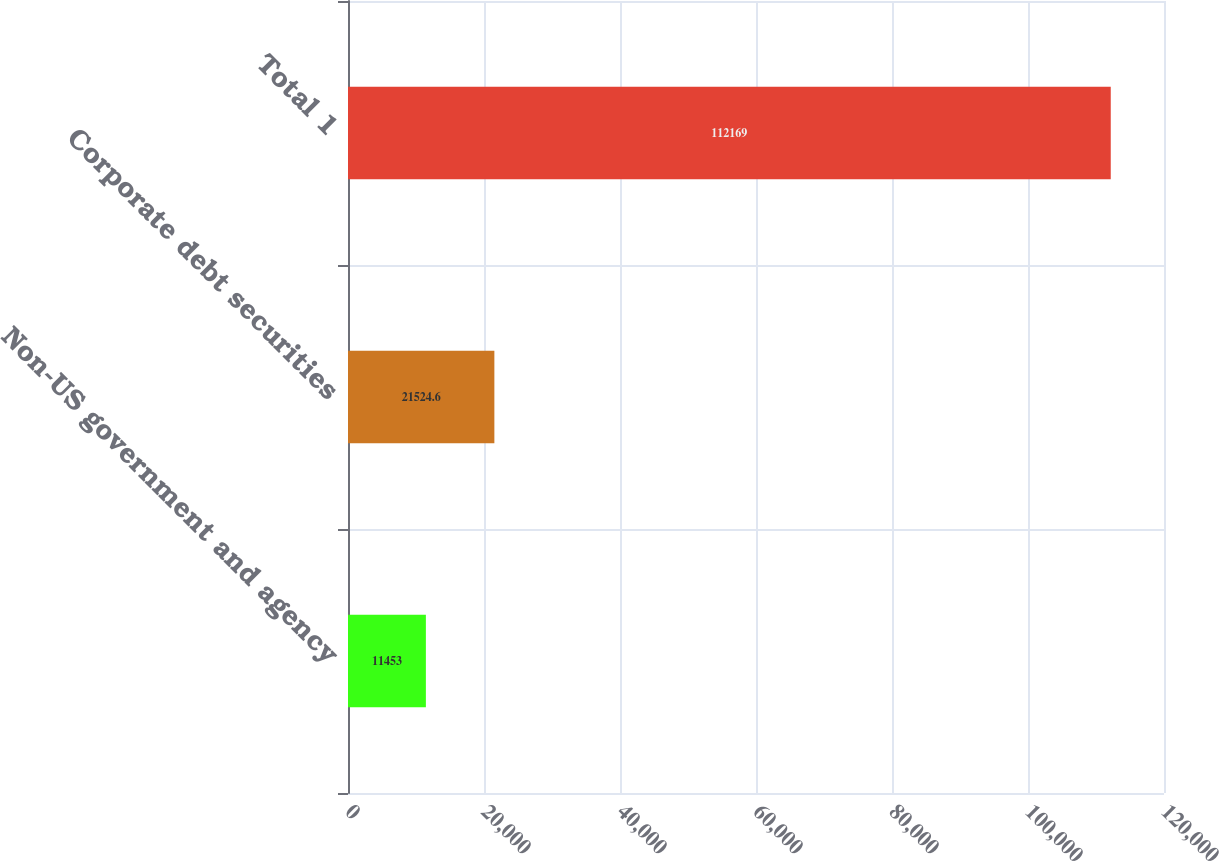Convert chart to OTSL. <chart><loc_0><loc_0><loc_500><loc_500><bar_chart><fcel>Non-US government and agency<fcel>Corporate debt securities<fcel>Total 1<nl><fcel>11453<fcel>21524.6<fcel>112169<nl></chart> 